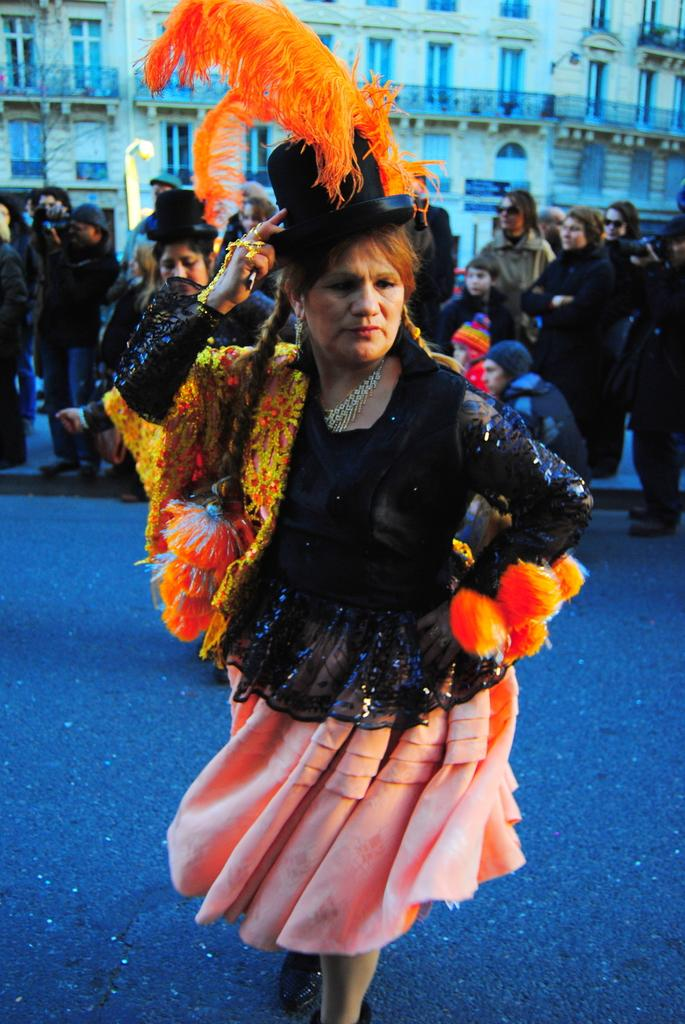What is the main subject of the image? The main subject of the image is a woman. What is the woman wearing in the image? The woman is wearing a costume in the image. What is the woman doing in the image? The woman is dancing on the road in the image. What can be seen in the background of the image? There is a crowd of people and a building in the background of the image. What grade is the creature in the image attending? There is no creature present in the image, and therefore no grade can be determined. 